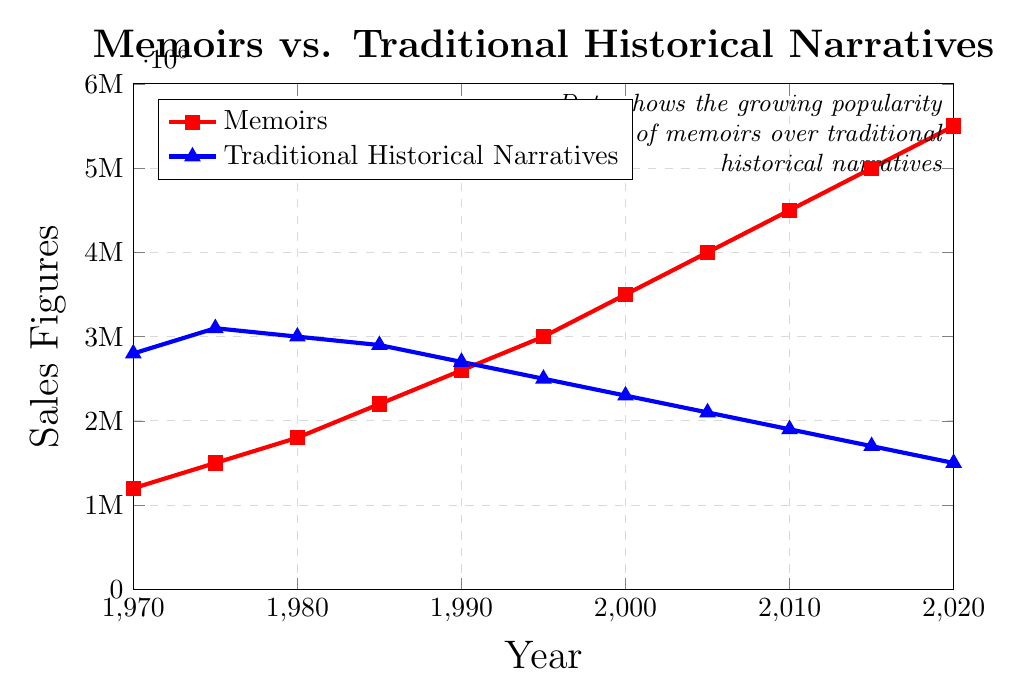What's the trend for memoir sales over the past 50 years? The plot shows an increasing trend for memoir sales. From 1970 to 2020, the sales consistently rise, starting from 1,200,000 in 1970 to 5,500,000 in 2020.
Answer: Increasing How do the sales of traditional historical narratives in 1980 compare to the sales in 2020? In 1980, the sales of traditional historical narratives were 3,000,000. By 2020, the sales had decreased to 1,500,000. Comparing these figures shows that sales declined by 1,500,000.
Answer: Decreased by 1,500,000 Which category has higher sales in 1990, memoirs or traditional historical narratives? In 1990, memoirs had sales of 2,600,000, while traditional historical narratives had sales of 2,700,000. Traditional historical narratives had higher sales.
Answer: Traditional historical narratives By how much did memoir sales increase from 1995 to 2000? Memoir sales increased from 3,000,000 in 1995 to 3,500,000 in 2000. The increase is calculated by subtracting 3,000,000 from 3,500,000, resulting in an increase of 500,000.
Answer: 500,000 What is the general trend observed for traditional historical narratives sales over the 50-year period? The plot shows that the sales of traditional historical narratives consistently decrease over the 50-year period. Starting from 2,800,000 in 1970, they continually decline to 1,500,000 by 2020.
Answer: Decreasing What can you infer about the popularity of memoirs versus traditional historical narratives in 2010? In 2010, memoirs had sales of 4,500,000, whereas traditional historical narratives had sales of 1,900,000. This suggests that memoirs were more popular in 2010.
Answer: Memoirs were more popular Calculate the average sales for memoirs from 1970 to 2020. To find the average, sum the sales figures for memoirs from 1970 to 2020: 1,200,000 + 1,500,000 + 1,800,000 + 2,200,000 + 2,600,000 + 3,000,000 + 3,500,000 + 4,000,000 + 4,500,000 + 5,000,000 + 5,500,000 = 38,800,000. Divide by the number of data points, which is 11. The average is 38,800,000 / 11 = 3,527,273.
Answer: 3,527,273 In which year did memoirs surpass traditional historical narratives in sales? By examining the plot, memoirs surpassed traditional historical narratives in 1990, where memoirs had 2,600,000 in sales and traditional historical narratives had 2,700,000. After 1990, memoirs continued to have higher sales.
Answer: 1990 What is the ratio of memoir sales to traditional historical narrative sales in 2020? In 2020, the sales of memoirs were 5,500,000 and traditional historical narratives were 1,500,000. The ratio is calculated by dividing 5,500,000 by 1,500,000, resulting in approximately 3.67.
Answer: 3.67 